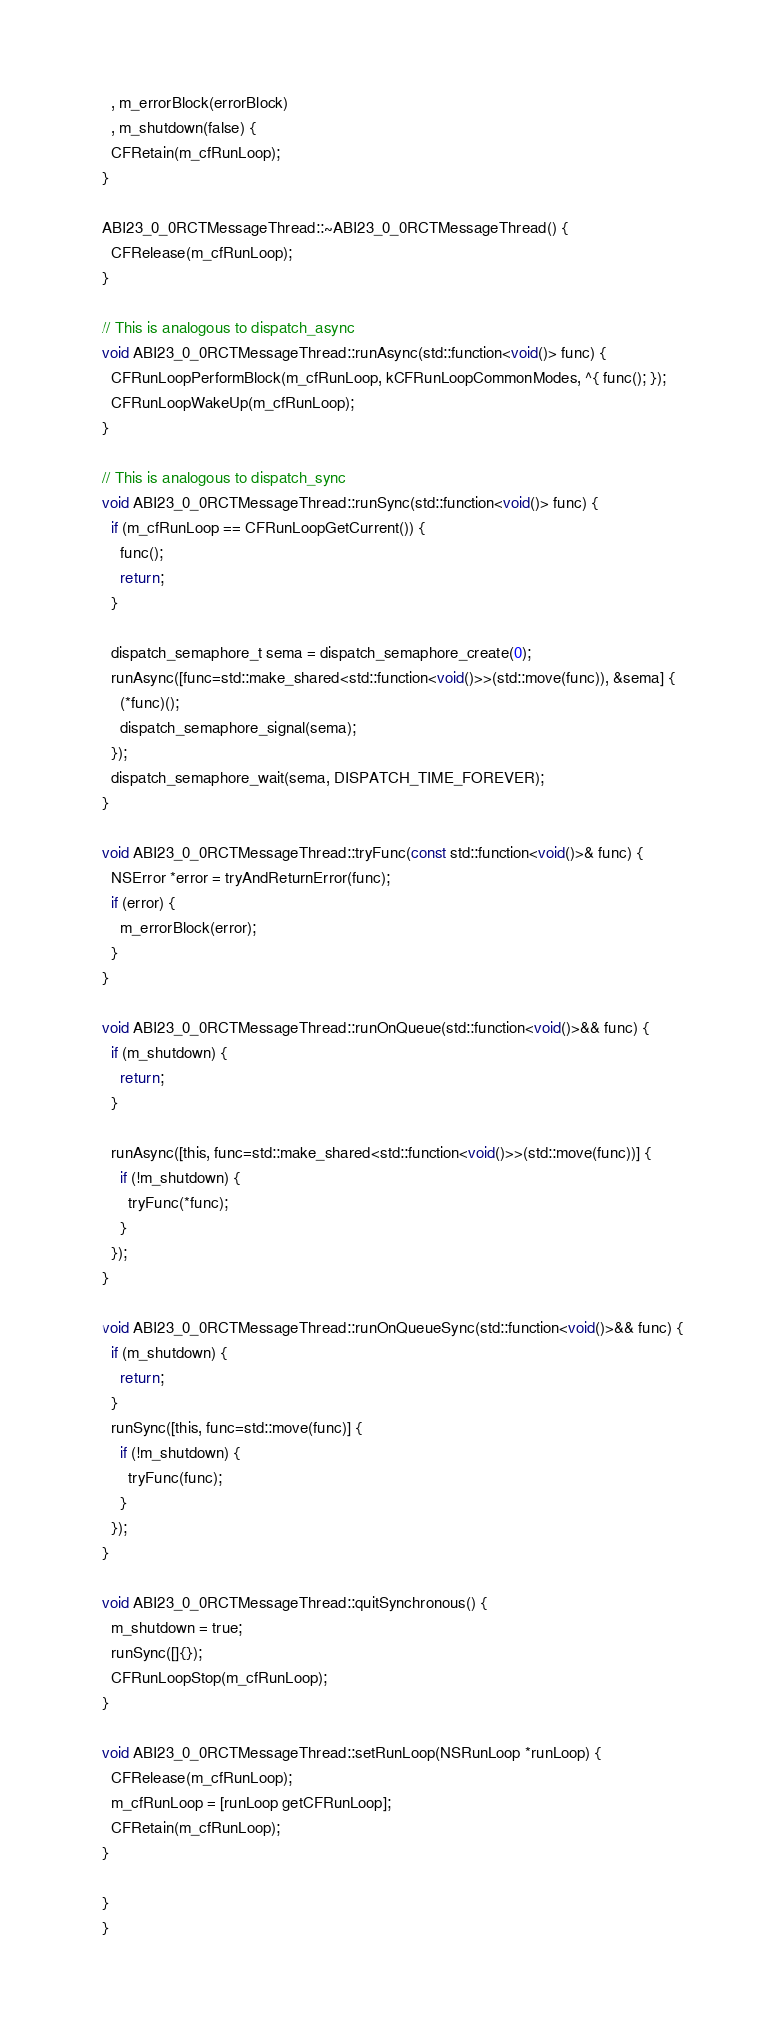Convert code to text. <code><loc_0><loc_0><loc_500><loc_500><_ObjectiveC_>  , m_errorBlock(errorBlock)
  , m_shutdown(false) {
  CFRetain(m_cfRunLoop);
}

ABI23_0_0RCTMessageThread::~ABI23_0_0RCTMessageThread() {
  CFRelease(m_cfRunLoop);
}

// This is analogous to dispatch_async
void ABI23_0_0RCTMessageThread::runAsync(std::function<void()> func) {
  CFRunLoopPerformBlock(m_cfRunLoop, kCFRunLoopCommonModes, ^{ func(); });
  CFRunLoopWakeUp(m_cfRunLoop);
}

// This is analogous to dispatch_sync
void ABI23_0_0RCTMessageThread::runSync(std::function<void()> func) {
  if (m_cfRunLoop == CFRunLoopGetCurrent()) {
    func();
    return;
  }

  dispatch_semaphore_t sema = dispatch_semaphore_create(0);
  runAsync([func=std::make_shared<std::function<void()>>(std::move(func)), &sema] {
    (*func)();
    dispatch_semaphore_signal(sema);
  });
  dispatch_semaphore_wait(sema, DISPATCH_TIME_FOREVER);
}

void ABI23_0_0RCTMessageThread::tryFunc(const std::function<void()>& func) {
  NSError *error = tryAndReturnError(func);
  if (error) {
    m_errorBlock(error);
  }
}

void ABI23_0_0RCTMessageThread::runOnQueue(std::function<void()>&& func) {
  if (m_shutdown) {
    return;
  }

  runAsync([this, func=std::make_shared<std::function<void()>>(std::move(func))] {
    if (!m_shutdown) {
      tryFunc(*func);
    }
  });
}

void ABI23_0_0RCTMessageThread::runOnQueueSync(std::function<void()>&& func) {
  if (m_shutdown) {
    return;
  }
  runSync([this, func=std::move(func)] {
    if (!m_shutdown) {
      tryFunc(func);
    }
  });
}

void ABI23_0_0RCTMessageThread::quitSynchronous() {
  m_shutdown = true;
  runSync([]{});
  CFRunLoopStop(m_cfRunLoop);
}

void ABI23_0_0RCTMessageThread::setRunLoop(NSRunLoop *runLoop) {
  CFRelease(m_cfRunLoop);
  m_cfRunLoop = [runLoop getCFRunLoop];
  CFRetain(m_cfRunLoop);
}

}
}
</code> 